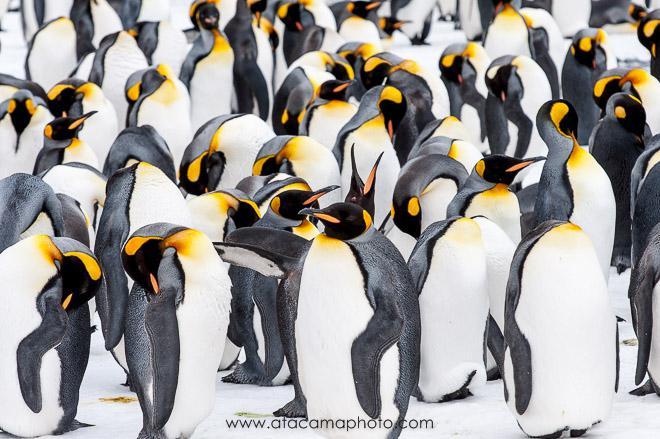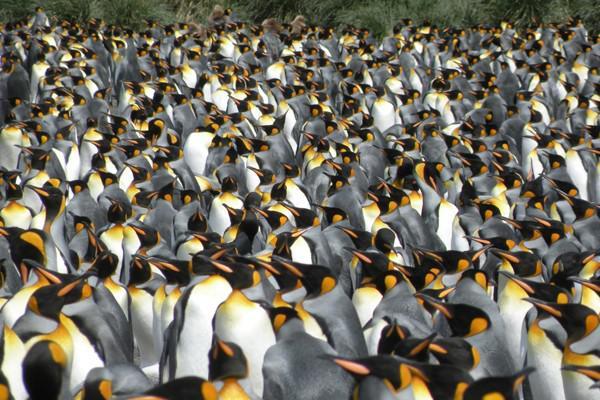The first image is the image on the left, the second image is the image on the right. Analyze the images presented: Is the assertion "At least one of the penguins has an open beak in one of the images." valid? Answer yes or no. Yes. 